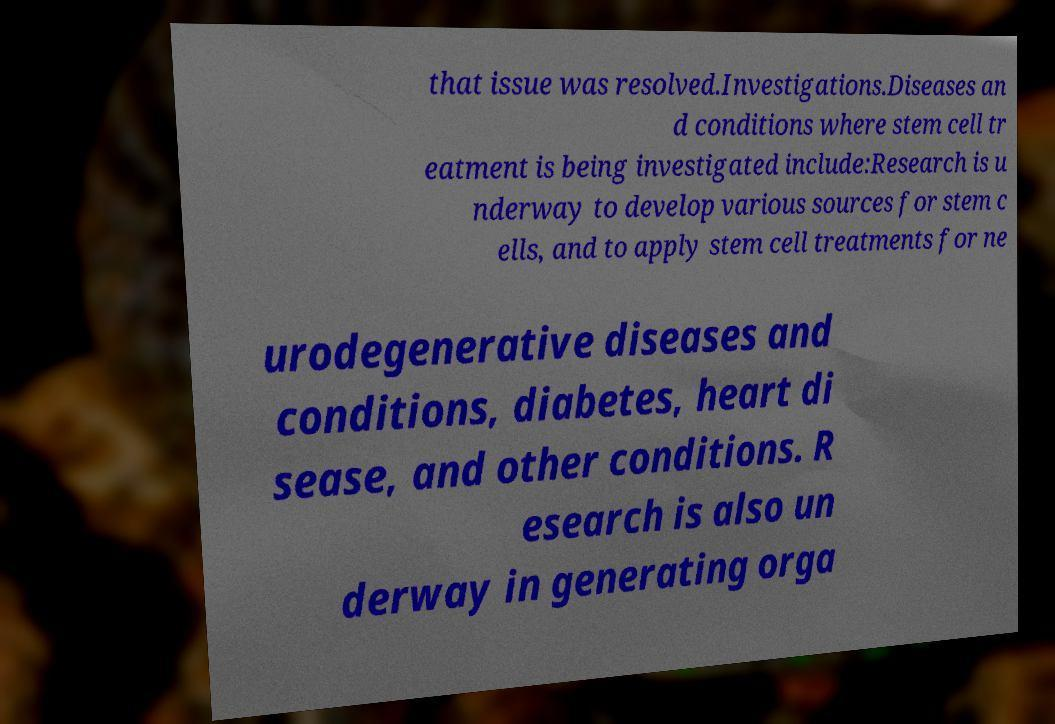I need the written content from this picture converted into text. Can you do that? that issue was resolved.Investigations.Diseases an d conditions where stem cell tr eatment is being investigated include:Research is u nderway to develop various sources for stem c ells, and to apply stem cell treatments for ne urodegenerative diseases and conditions, diabetes, heart di sease, and other conditions. R esearch is also un derway in generating orga 